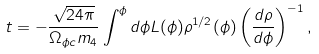Convert formula to latex. <formula><loc_0><loc_0><loc_500><loc_500>t = - \frac { \sqrt { 2 4 \pi } } { \Omega _ { \phi c } m _ { 4 } } \int ^ { \phi } d \phi L ( \phi ) \rho ^ { 1 / 2 } ( \phi ) \left ( \frac { d \rho } { d \phi } \right ) ^ { - 1 } ,</formula> 